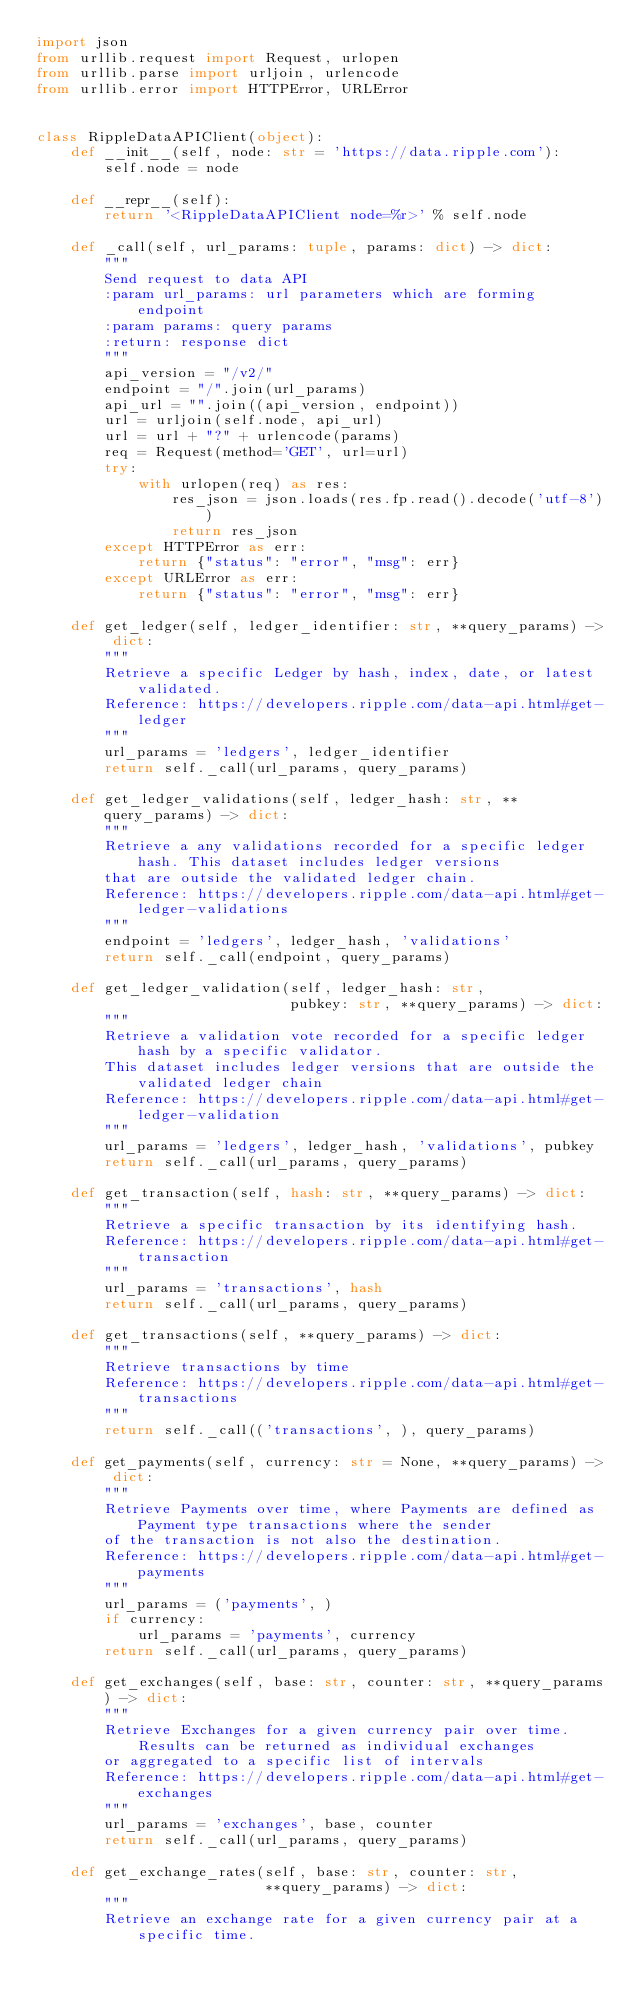Convert code to text. <code><loc_0><loc_0><loc_500><loc_500><_Python_>import json
from urllib.request import Request, urlopen
from urllib.parse import urljoin, urlencode
from urllib.error import HTTPError, URLError


class RippleDataAPIClient(object):
    def __init__(self, node: str = 'https://data.ripple.com'):
        self.node = node

    def __repr__(self):
        return '<RippleDataAPIClient node=%r>' % self.node

    def _call(self, url_params: tuple, params: dict) -> dict:
        """
        Send request to data API
        :param url_params: url parameters which are forming endpoint
        :param params: query params
        :return: response dict
        """
        api_version = "/v2/"
        endpoint = "/".join(url_params)
        api_url = "".join((api_version, endpoint))
        url = urljoin(self.node, api_url)
        url = url + "?" + urlencode(params)
        req = Request(method='GET', url=url)
        try:
            with urlopen(req) as res:
                res_json = json.loads(res.fp.read().decode('utf-8'))
                return res_json
        except HTTPError as err:
            return {"status": "error", "msg": err}
        except URLError as err:
            return {"status": "error", "msg": err}

    def get_ledger(self, ledger_identifier: str, **query_params) -> dict:
        """
        Retrieve a specific Ledger by hash, index, date, or latest validated.
        Reference: https://developers.ripple.com/data-api.html#get-ledger
        """
        url_params = 'ledgers', ledger_identifier
        return self._call(url_params, query_params)

    def get_ledger_validations(self, ledger_hash: str, **query_params) -> dict:
        """
        Retrieve a any validations recorded for a specific ledger hash. This dataset includes ledger versions
        that are outside the validated ledger chain.
        Reference: https://developers.ripple.com/data-api.html#get-ledger-validations
        """
        endpoint = 'ledgers', ledger_hash, 'validations'
        return self._call(endpoint, query_params)

    def get_ledger_validation(self, ledger_hash: str,
                              pubkey: str, **query_params) -> dict:
        """
        Retrieve a validation vote recorded for a specific ledger hash by a specific validator.
        This dataset includes ledger versions that are outside the validated ledger chain
        Reference: https://developers.ripple.com/data-api.html#get-ledger-validation
        """
        url_params = 'ledgers', ledger_hash, 'validations', pubkey
        return self._call(url_params, query_params)

    def get_transaction(self, hash: str, **query_params) -> dict:
        """
        Retrieve a specific transaction by its identifying hash.
        Reference: https://developers.ripple.com/data-api.html#get-transaction
        """
        url_params = 'transactions', hash
        return self._call(url_params, query_params)

    def get_transactions(self, **query_params) -> dict:
        """
        Retrieve transactions by time
        Reference: https://developers.ripple.com/data-api.html#get-transactions
        """
        return self._call(('transactions', ), query_params)

    def get_payments(self, currency: str = None, **query_params) -> dict:
        """
        Retrieve Payments over time, where Payments are defined as Payment type transactions where the sender
        of the transaction is not also the destination.
        Reference: https://developers.ripple.com/data-api.html#get-payments
        """
        url_params = ('payments', )
        if currency:
            url_params = 'payments', currency
        return self._call(url_params, query_params)

    def get_exchanges(self, base: str, counter: str, **query_params) -> dict:
        """
        Retrieve Exchanges for a given currency pair over time. Results can be returned as individual exchanges
        or aggregated to a specific list of intervals
        Reference: https://developers.ripple.com/data-api.html#get-exchanges
        """
        url_params = 'exchanges', base, counter
        return self._call(url_params, query_params)

    def get_exchange_rates(self, base: str, counter: str,
                           **query_params) -> dict:
        """
        Retrieve an exchange rate for a given currency pair at a specific time.</code> 